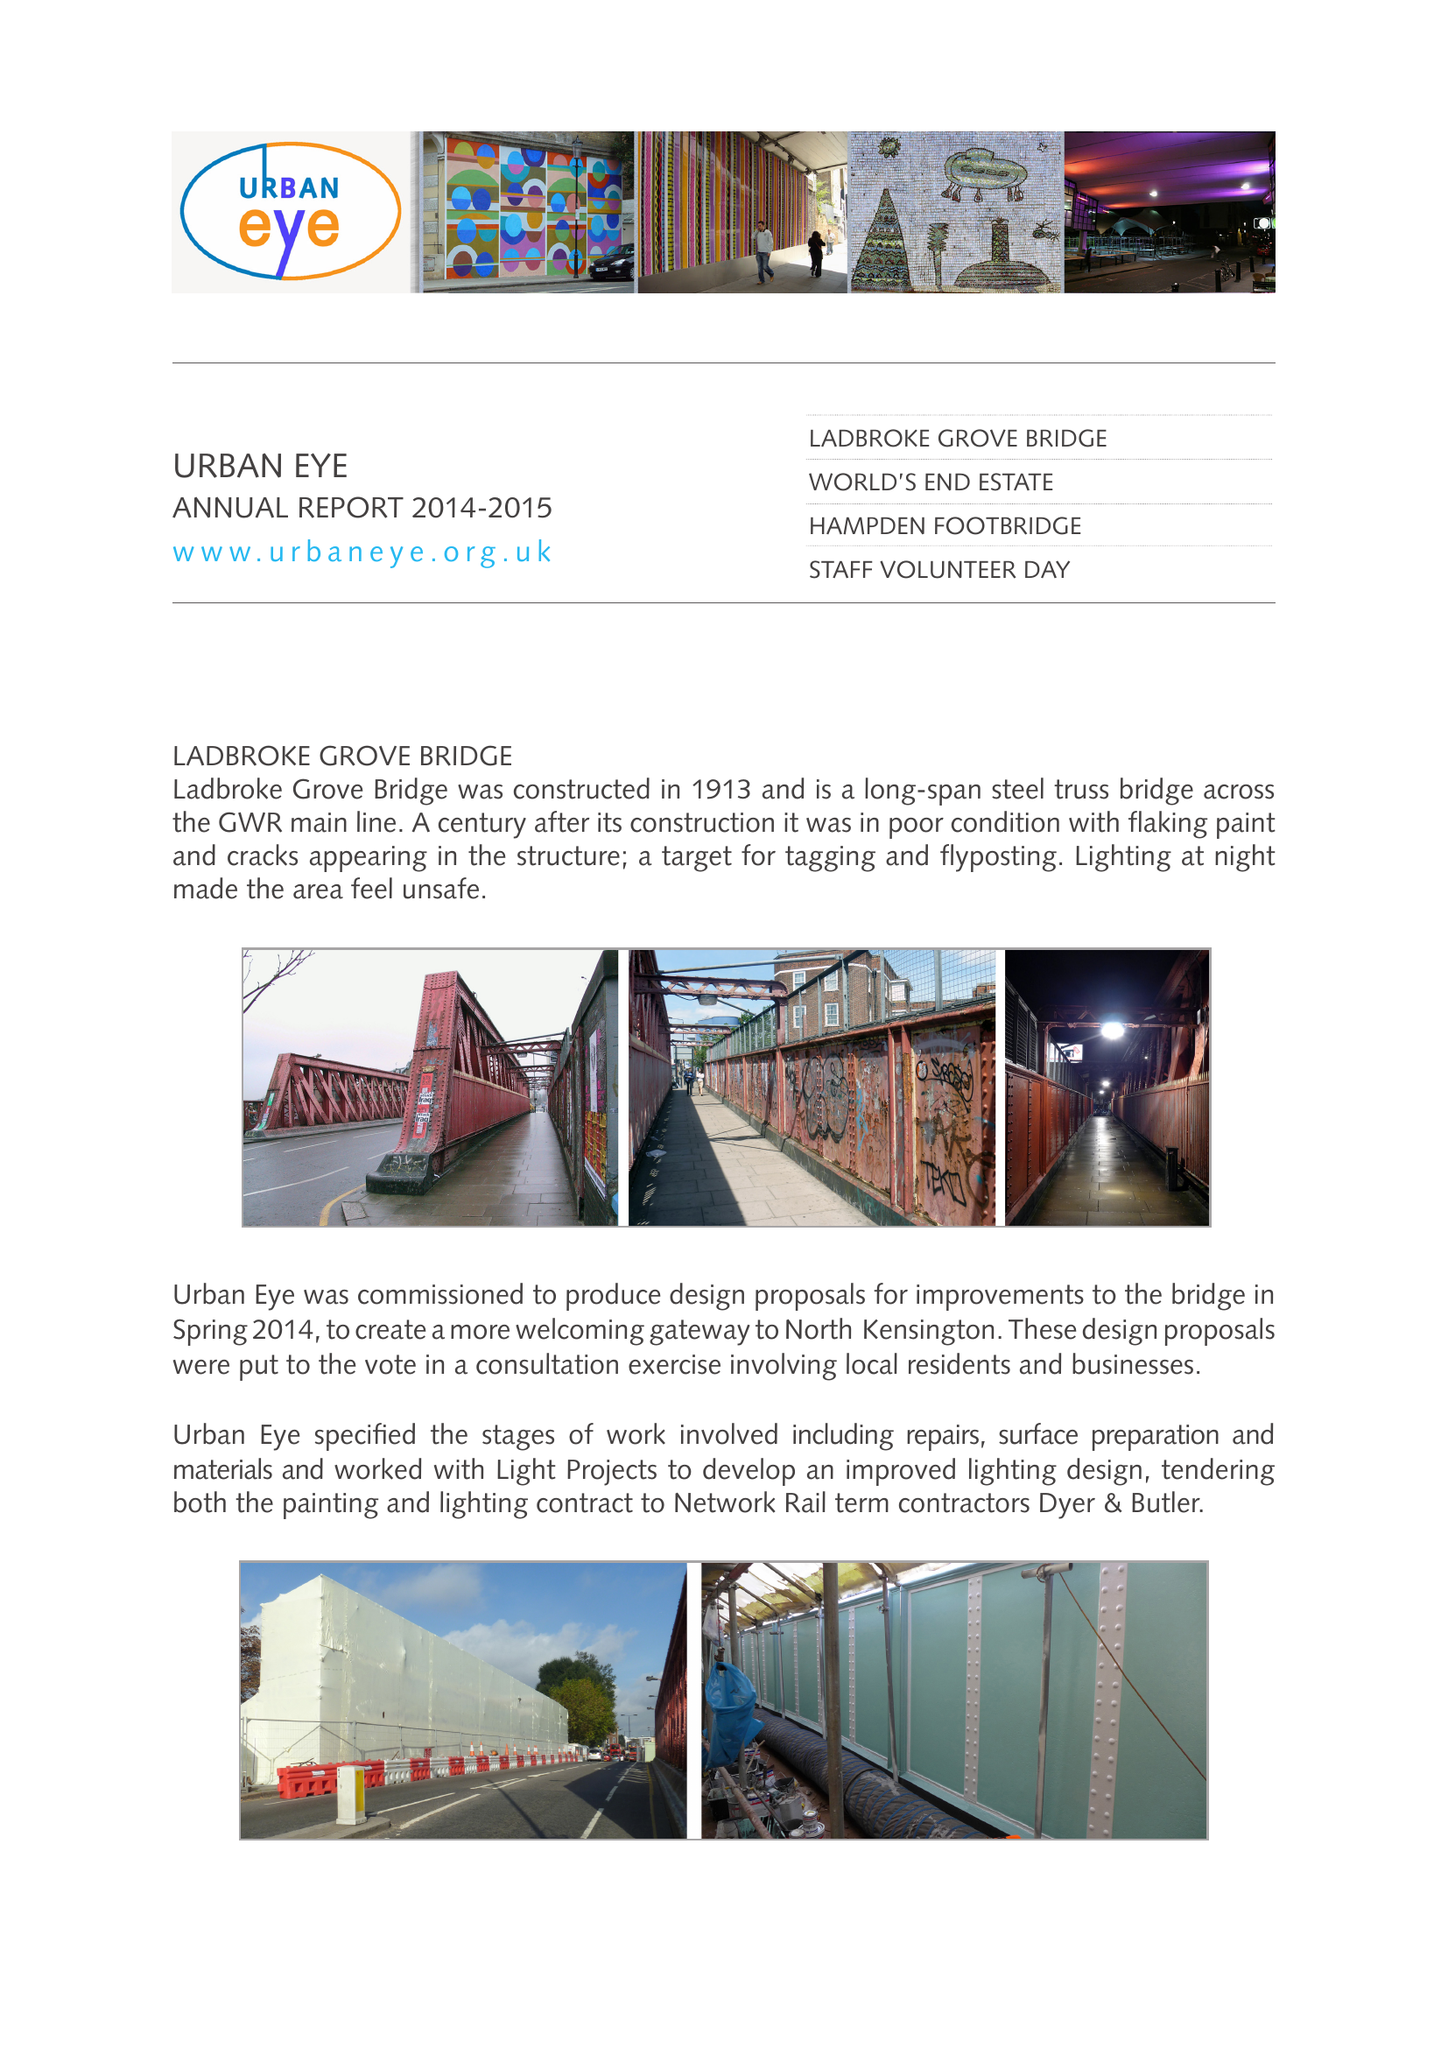What is the value for the address__postcode?
Answer the question using a single word or phrase. W11 4AT 